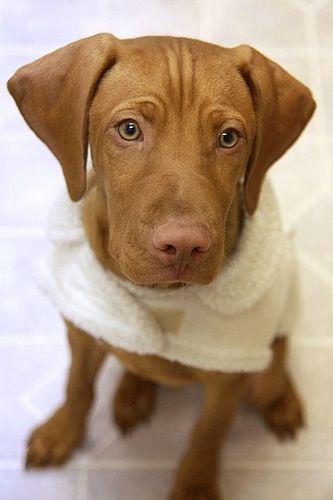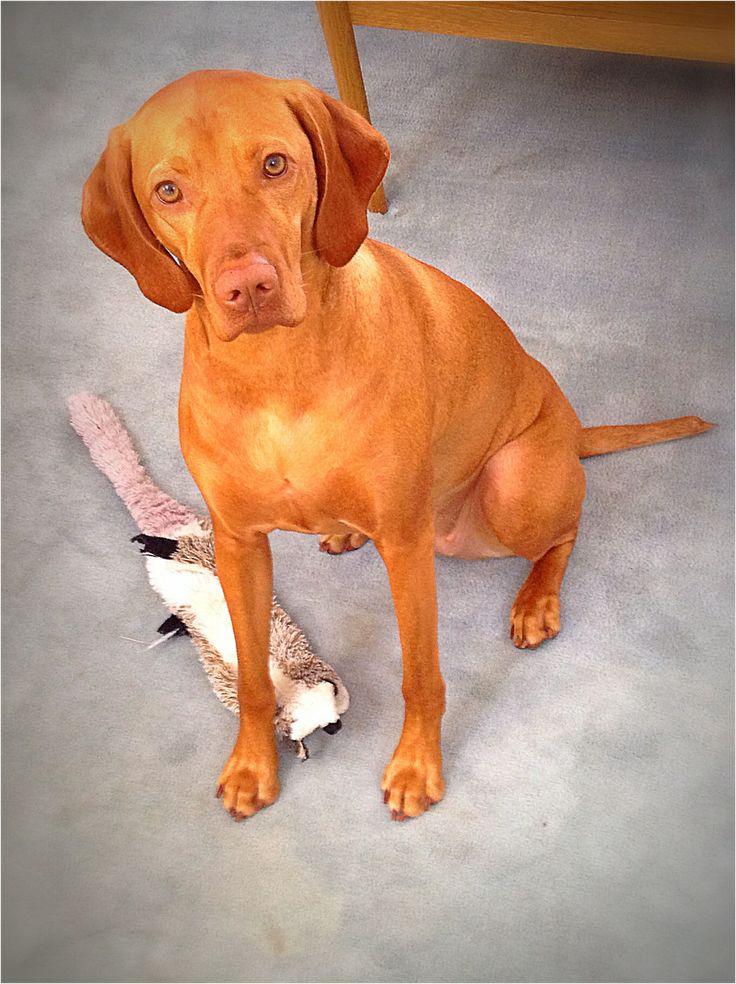The first image is the image on the left, the second image is the image on the right. Evaluate the accuracy of this statement regarding the images: "A Vizsla dog is lying on a blanket.". Is it true? Answer yes or no. No. The first image is the image on the left, the second image is the image on the right. For the images shown, is this caption "Each image contains a single red-orange dog, and the right image contains an upward-gazing dog in a sitting pose with a toy stuffed animal by one foot." true? Answer yes or no. Yes. 